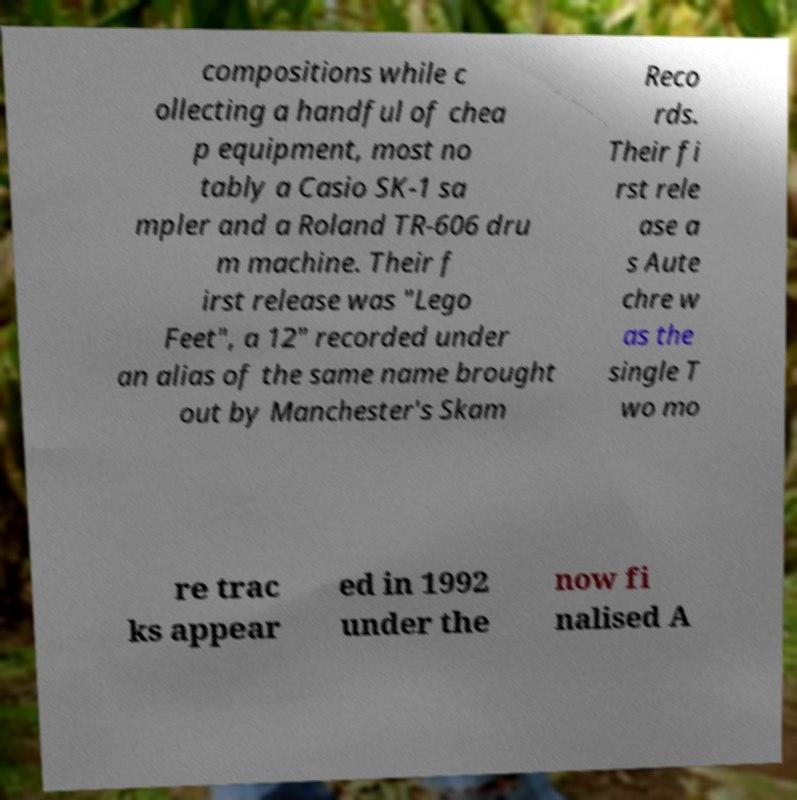Please identify and transcribe the text found in this image. compositions while c ollecting a handful of chea p equipment, most no tably a Casio SK-1 sa mpler and a Roland TR-606 dru m machine. Their f irst release was "Lego Feet", a 12" recorded under an alias of the same name brought out by Manchester's Skam Reco rds. Their fi rst rele ase a s Aute chre w as the single T wo mo re trac ks appear ed in 1992 under the now fi nalised A 